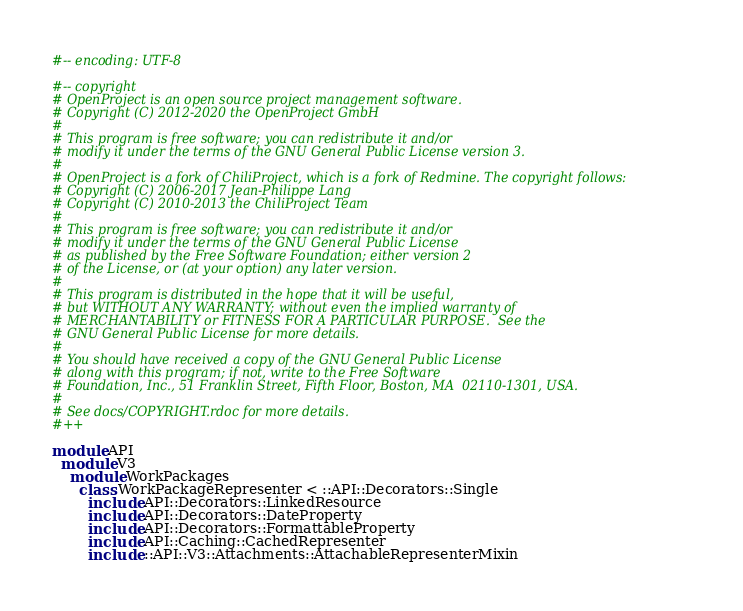<code> <loc_0><loc_0><loc_500><loc_500><_Ruby_>#-- encoding: UTF-8

#-- copyright
# OpenProject is an open source project management software.
# Copyright (C) 2012-2020 the OpenProject GmbH
#
# This program is free software; you can redistribute it and/or
# modify it under the terms of the GNU General Public License version 3.
#
# OpenProject is a fork of ChiliProject, which is a fork of Redmine. The copyright follows:
# Copyright (C) 2006-2017 Jean-Philippe Lang
# Copyright (C) 2010-2013 the ChiliProject Team
#
# This program is free software; you can redistribute it and/or
# modify it under the terms of the GNU General Public License
# as published by the Free Software Foundation; either version 2
# of the License, or (at your option) any later version.
#
# This program is distributed in the hope that it will be useful,
# but WITHOUT ANY WARRANTY; without even the implied warranty of
# MERCHANTABILITY or FITNESS FOR A PARTICULAR PURPOSE.  See the
# GNU General Public License for more details.
#
# You should have received a copy of the GNU General Public License
# along with this program; if not, write to the Free Software
# Foundation, Inc., 51 Franklin Street, Fifth Floor, Boston, MA  02110-1301, USA.
#
# See docs/COPYRIGHT.rdoc for more details.
#++

module API
  module V3
    module WorkPackages
      class WorkPackageRepresenter < ::API::Decorators::Single
        include API::Decorators::LinkedResource
        include API::Decorators::DateProperty
        include API::Decorators::FormattableProperty
        include API::Caching::CachedRepresenter
        include ::API::V3::Attachments::AttachableRepresenterMixin</code> 